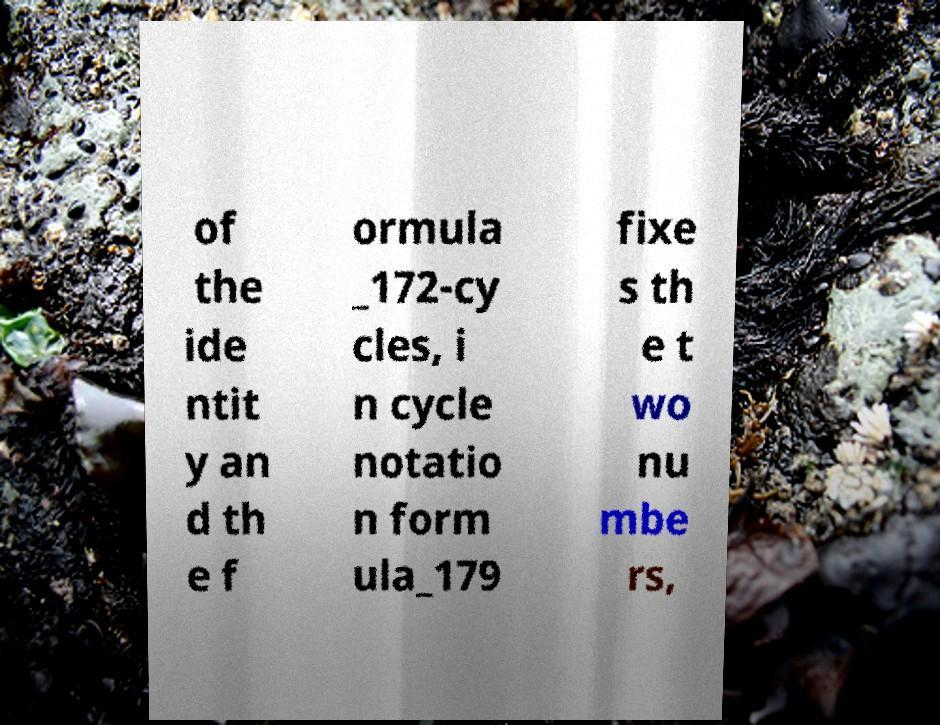There's text embedded in this image that I need extracted. Can you transcribe it verbatim? of the ide ntit y an d th e f ormula _172-cy cles, i n cycle notatio n form ula_179 fixe s th e t wo nu mbe rs, 